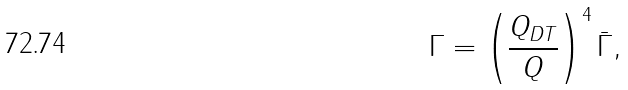Convert formula to latex. <formula><loc_0><loc_0><loc_500><loc_500>\Gamma = \left ( \frac { Q _ { D T } } { Q } \right ) ^ { 4 } { \bar { \Gamma } } ,</formula> 